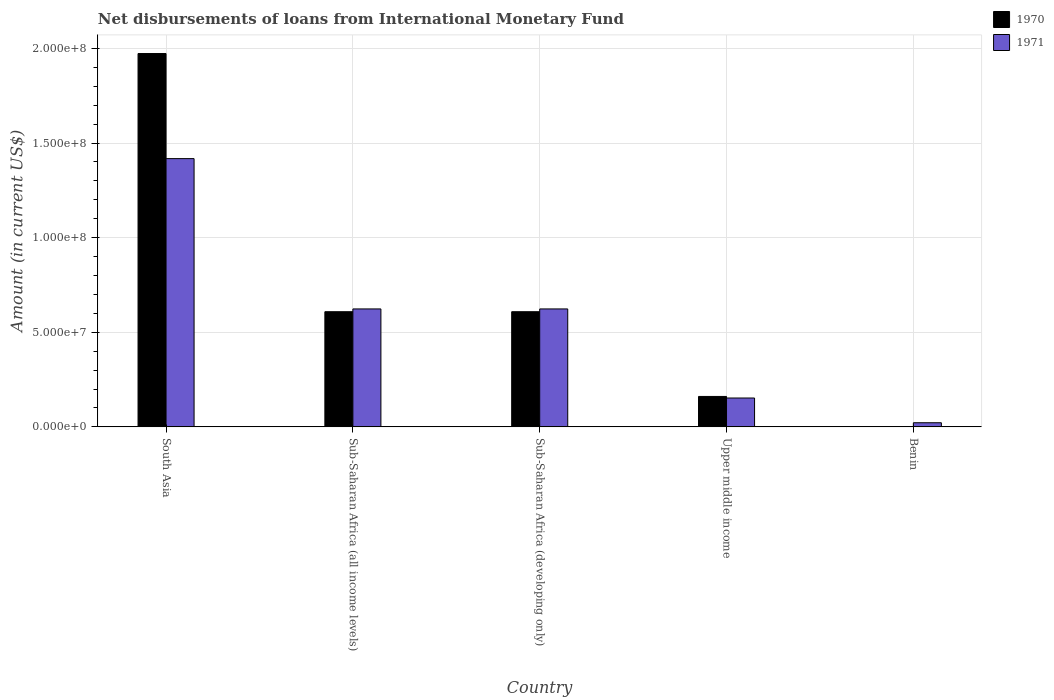How many different coloured bars are there?
Your response must be concise. 2. Are the number of bars per tick equal to the number of legend labels?
Keep it short and to the point. Yes. Are the number of bars on each tick of the X-axis equal?
Your answer should be very brief. Yes. What is the label of the 5th group of bars from the left?
Your answer should be very brief. Benin. In how many cases, is the number of bars for a given country not equal to the number of legend labels?
Offer a very short reply. 0. What is the amount of loans disbursed in 1971 in South Asia?
Ensure brevity in your answer.  1.42e+08. Across all countries, what is the maximum amount of loans disbursed in 1970?
Provide a succinct answer. 1.97e+08. Across all countries, what is the minimum amount of loans disbursed in 1971?
Keep it short and to the point. 2.19e+06. In which country was the amount of loans disbursed in 1970 minimum?
Provide a short and direct response. Benin. What is the total amount of loans disbursed in 1971 in the graph?
Offer a terse response. 2.84e+08. What is the difference between the amount of loans disbursed in 1970 in Benin and that in Sub-Saharan Africa (all income levels)?
Provide a short and direct response. -6.07e+07. What is the difference between the amount of loans disbursed in 1970 in Benin and the amount of loans disbursed in 1971 in Sub-Saharan Africa (developing only)?
Provide a succinct answer. -6.22e+07. What is the average amount of loans disbursed in 1971 per country?
Keep it short and to the point. 5.68e+07. What is the difference between the amount of loans disbursed of/in 1970 and amount of loans disbursed of/in 1971 in South Asia?
Offer a very short reply. 5.55e+07. In how many countries, is the amount of loans disbursed in 1970 greater than 80000000 US$?
Provide a succinct answer. 1. What is the ratio of the amount of loans disbursed in 1970 in South Asia to that in Upper middle income?
Your answer should be compact. 12.27. Is the difference between the amount of loans disbursed in 1970 in Benin and Upper middle income greater than the difference between the amount of loans disbursed in 1971 in Benin and Upper middle income?
Keep it short and to the point. No. What is the difference between the highest and the second highest amount of loans disbursed in 1970?
Your response must be concise. 1.36e+08. What is the difference between the highest and the lowest amount of loans disbursed in 1970?
Offer a terse response. 1.97e+08. In how many countries, is the amount of loans disbursed in 1971 greater than the average amount of loans disbursed in 1971 taken over all countries?
Make the answer very short. 3. How many bars are there?
Offer a very short reply. 10. Are all the bars in the graph horizontal?
Offer a terse response. No. Does the graph contain any zero values?
Make the answer very short. No. Does the graph contain grids?
Ensure brevity in your answer.  Yes. Where does the legend appear in the graph?
Offer a terse response. Top right. How are the legend labels stacked?
Offer a very short reply. Vertical. What is the title of the graph?
Your response must be concise. Net disbursements of loans from International Monetary Fund. Does "2011" appear as one of the legend labels in the graph?
Offer a terse response. No. What is the label or title of the X-axis?
Offer a very short reply. Country. What is the Amount (in current US$) of 1970 in South Asia?
Give a very brief answer. 1.97e+08. What is the Amount (in current US$) in 1971 in South Asia?
Keep it short and to the point. 1.42e+08. What is the Amount (in current US$) in 1970 in Sub-Saharan Africa (all income levels)?
Your answer should be very brief. 6.09e+07. What is the Amount (in current US$) of 1971 in Sub-Saharan Africa (all income levels)?
Provide a short and direct response. 6.23e+07. What is the Amount (in current US$) of 1970 in Sub-Saharan Africa (developing only)?
Make the answer very short. 6.09e+07. What is the Amount (in current US$) in 1971 in Sub-Saharan Africa (developing only)?
Make the answer very short. 6.23e+07. What is the Amount (in current US$) of 1970 in Upper middle income?
Give a very brief answer. 1.61e+07. What is the Amount (in current US$) in 1971 in Upper middle income?
Your answer should be compact. 1.52e+07. What is the Amount (in current US$) in 1970 in Benin?
Offer a very short reply. 1.45e+05. What is the Amount (in current US$) in 1971 in Benin?
Provide a succinct answer. 2.19e+06. Across all countries, what is the maximum Amount (in current US$) in 1970?
Offer a terse response. 1.97e+08. Across all countries, what is the maximum Amount (in current US$) of 1971?
Give a very brief answer. 1.42e+08. Across all countries, what is the minimum Amount (in current US$) in 1970?
Your answer should be compact. 1.45e+05. Across all countries, what is the minimum Amount (in current US$) in 1971?
Provide a short and direct response. 2.19e+06. What is the total Amount (in current US$) of 1970 in the graph?
Offer a terse response. 3.35e+08. What is the total Amount (in current US$) of 1971 in the graph?
Your answer should be compact. 2.84e+08. What is the difference between the Amount (in current US$) in 1970 in South Asia and that in Sub-Saharan Africa (all income levels)?
Your answer should be very brief. 1.36e+08. What is the difference between the Amount (in current US$) in 1971 in South Asia and that in Sub-Saharan Africa (all income levels)?
Make the answer very short. 7.94e+07. What is the difference between the Amount (in current US$) in 1970 in South Asia and that in Sub-Saharan Africa (developing only)?
Ensure brevity in your answer.  1.36e+08. What is the difference between the Amount (in current US$) of 1971 in South Asia and that in Sub-Saharan Africa (developing only)?
Your response must be concise. 7.94e+07. What is the difference between the Amount (in current US$) in 1970 in South Asia and that in Upper middle income?
Give a very brief answer. 1.81e+08. What is the difference between the Amount (in current US$) of 1971 in South Asia and that in Upper middle income?
Offer a very short reply. 1.26e+08. What is the difference between the Amount (in current US$) of 1970 in South Asia and that in Benin?
Offer a very short reply. 1.97e+08. What is the difference between the Amount (in current US$) of 1971 in South Asia and that in Benin?
Make the answer very short. 1.40e+08. What is the difference between the Amount (in current US$) of 1970 in Sub-Saharan Africa (all income levels) and that in Upper middle income?
Make the answer very short. 4.48e+07. What is the difference between the Amount (in current US$) in 1971 in Sub-Saharan Africa (all income levels) and that in Upper middle income?
Keep it short and to the point. 4.71e+07. What is the difference between the Amount (in current US$) of 1970 in Sub-Saharan Africa (all income levels) and that in Benin?
Offer a very short reply. 6.07e+07. What is the difference between the Amount (in current US$) of 1971 in Sub-Saharan Africa (all income levels) and that in Benin?
Make the answer very short. 6.01e+07. What is the difference between the Amount (in current US$) in 1970 in Sub-Saharan Africa (developing only) and that in Upper middle income?
Make the answer very short. 4.48e+07. What is the difference between the Amount (in current US$) in 1971 in Sub-Saharan Africa (developing only) and that in Upper middle income?
Ensure brevity in your answer.  4.71e+07. What is the difference between the Amount (in current US$) in 1970 in Sub-Saharan Africa (developing only) and that in Benin?
Make the answer very short. 6.07e+07. What is the difference between the Amount (in current US$) of 1971 in Sub-Saharan Africa (developing only) and that in Benin?
Give a very brief answer. 6.01e+07. What is the difference between the Amount (in current US$) in 1970 in Upper middle income and that in Benin?
Your answer should be compact. 1.59e+07. What is the difference between the Amount (in current US$) in 1971 in Upper middle income and that in Benin?
Your answer should be very brief. 1.31e+07. What is the difference between the Amount (in current US$) in 1970 in South Asia and the Amount (in current US$) in 1971 in Sub-Saharan Africa (all income levels)?
Offer a very short reply. 1.35e+08. What is the difference between the Amount (in current US$) in 1970 in South Asia and the Amount (in current US$) in 1971 in Sub-Saharan Africa (developing only)?
Give a very brief answer. 1.35e+08. What is the difference between the Amount (in current US$) in 1970 in South Asia and the Amount (in current US$) in 1971 in Upper middle income?
Provide a short and direct response. 1.82e+08. What is the difference between the Amount (in current US$) in 1970 in South Asia and the Amount (in current US$) in 1971 in Benin?
Provide a short and direct response. 1.95e+08. What is the difference between the Amount (in current US$) in 1970 in Sub-Saharan Africa (all income levels) and the Amount (in current US$) in 1971 in Sub-Saharan Africa (developing only)?
Provide a short and direct response. -1.46e+06. What is the difference between the Amount (in current US$) in 1970 in Sub-Saharan Africa (all income levels) and the Amount (in current US$) in 1971 in Upper middle income?
Ensure brevity in your answer.  4.56e+07. What is the difference between the Amount (in current US$) of 1970 in Sub-Saharan Africa (all income levels) and the Amount (in current US$) of 1971 in Benin?
Provide a succinct answer. 5.87e+07. What is the difference between the Amount (in current US$) in 1970 in Sub-Saharan Africa (developing only) and the Amount (in current US$) in 1971 in Upper middle income?
Offer a terse response. 4.56e+07. What is the difference between the Amount (in current US$) of 1970 in Sub-Saharan Africa (developing only) and the Amount (in current US$) of 1971 in Benin?
Provide a short and direct response. 5.87e+07. What is the difference between the Amount (in current US$) of 1970 in Upper middle income and the Amount (in current US$) of 1971 in Benin?
Offer a very short reply. 1.39e+07. What is the average Amount (in current US$) in 1970 per country?
Provide a succinct answer. 6.70e+07. What is the average Amount (in current US$) in 1971 per country?
Keep it short and to the point. 5.68e+07. What is the difference between the Amount (in current US$) of 1970 and Amount (in current US$) of 1971 in South Asia?
Keep it short and to the point. 5.55e+07. What is the difference between the Amount (in current US$) of 1970 and Amount (in current US$) of 1971 in Sub-Saharan Africa (all income levels)?
Ensure brevity in your answer.  -1.46e+06. What is the difference between the Amount (in current US$) in 1970 and Amount (in current US$) in 1971 in Sub-Saharan Africa (developing only)?
Keep it short and to the point. -1.46e+06. What is the difference between the Amount (in current US$) in 1970 and Amount (in current US$) in 1971 in Upper middle income?
Your answer should be compact. 8.24e+05. What is the difference between the Amount (in current US$) of 1970 and Amount (in current US$) of 1971 in Benin?
Your answer should be compact. -2.04e+06. What is the ratio of the Amount (in current US$) in 1970 in South Asia to that in Sub-Saharan Africa (all income levels)?
Give a very brief answer. 3.24. What is the ratio of the Amount (in current US$) in 1971 in South Asia to that in Sub-Saharan Africa (all income levels)?
Give a very brief answer. 2.27. What is the ratio of the Amount (in current US$) of 1970 in South Asia to that in Sub-Saharan Africa (developing only)?
Your answer should be compact. 3.24. What is the ratio of the Amount (in current US$) in 1971 in South Asia to that in Sub-Saharan Africa (developing only)?
Offer a terse response. 2.27. What is the ratio of the Amount (in current US$) of 1970 in South Asia to that in Upper middle income?
Keep it short and to the point. 12.27. What is the ratio of the Amount (in current US$) in 1971 in South Asia to that in Upper middle income?
Make the answer very short. 9.29. What is the ratio of the Amount (in current US$) of 1970 in South Asia to that in Benin?
Provide a short and direct response. 1360.52. What is the ratio of the Amount (in current US$) of 1971 in South Asia to that in Benin?
Your answer should be very brief. 64.84. What is the ratio of the Amount (in current US$) of 1971 in Sub-Saharan Africa (all income levels) to that in Sub-Saharan Africa (developing only)?
Offer a terse response. 1. What is the ratio of the Amount (in current US$) in 1970 in Sub-Saharan Africa (all income levels) to that in Upper middle income?
Offer a terse response. 3.79. What is the ratio of the Amount (in current US$) in 1971 in Sub-Saharan Africa (all income levels) to that in Upper middle income?
Make the answer very short. 4.09. What is the ratio of the Amount (in current US$) in 1970 in Sub-Saharan Africa (all income levels) to that in Benin?
Ensure brevity in your answer.  419.7. What is the ratio of the Amount (in current US$) in 1971 in Sub-Saharan Africa (all income levels) to that in Benin?
Offer a terse response. 28.51. What is the ratio of the Amount (in current US$) in 1970 in Sub-Saharan Africa (developing only) to that in Upper middle income?
Provide a succinct answer. 3.79. What is the ratio of the Amount (in current US$) of 1971 in Sub-Saharan Africa (developing only) to that in Upper middle income?
Your answer should be very brief. 4.09. What is the ratio of the Amount (in current US$) in 1970 in Sub-Saharan Africa (developing only) to that in Benin?
Offer a terse response. 419.7. What is the ratio of the Amount (in current US$) in 1971 in Sub-Saharan Africa (developing only) to that in Benin?
Provide a succinct answer. 28.51. What is the ratio of the Amount (in current US$) in 1970 in Upper middle income to that in Benin?
Your answer should be very brief. 110.86. What is the ratio of the Amount (in current US$) of 1971 in Upper middle income to that in Benin?
Your response must be concise. 6.98. What is the difference between the highest and the second highest Amount (in current US$) of 1970?
Provide a short and direct response. 1.36e+08. What is the difference between the highest and the second highest Amount (in current US$) in 1971?
Make the answer very short. 7.94e+07. What is the difference between the highest and the lowest Amount (in current US$) in 1970?
Give a very brief answer. 1.97e+08. What is the difference between the highest and the lowest Amount (in current US$) in 1971?
Offer a very short reply. 1.40e+08. 